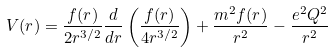<formula> <loc_0><loc_0><loc_500><loc_500>V ( r ) = \frac { f ( r ) } { 2 r ^ { 3 / 2 } } \frac { d } { d r } \left ( \frac { f ( r ) } { 4 r ^ { 3 / 2 } } \right ) + \frac { m ^ { 2 } f ( r ) } { r ^ { 2 } } - \frac { e ^ { 2 } Q ^ { 2 } } { r ^ { 2 } }</formula> 